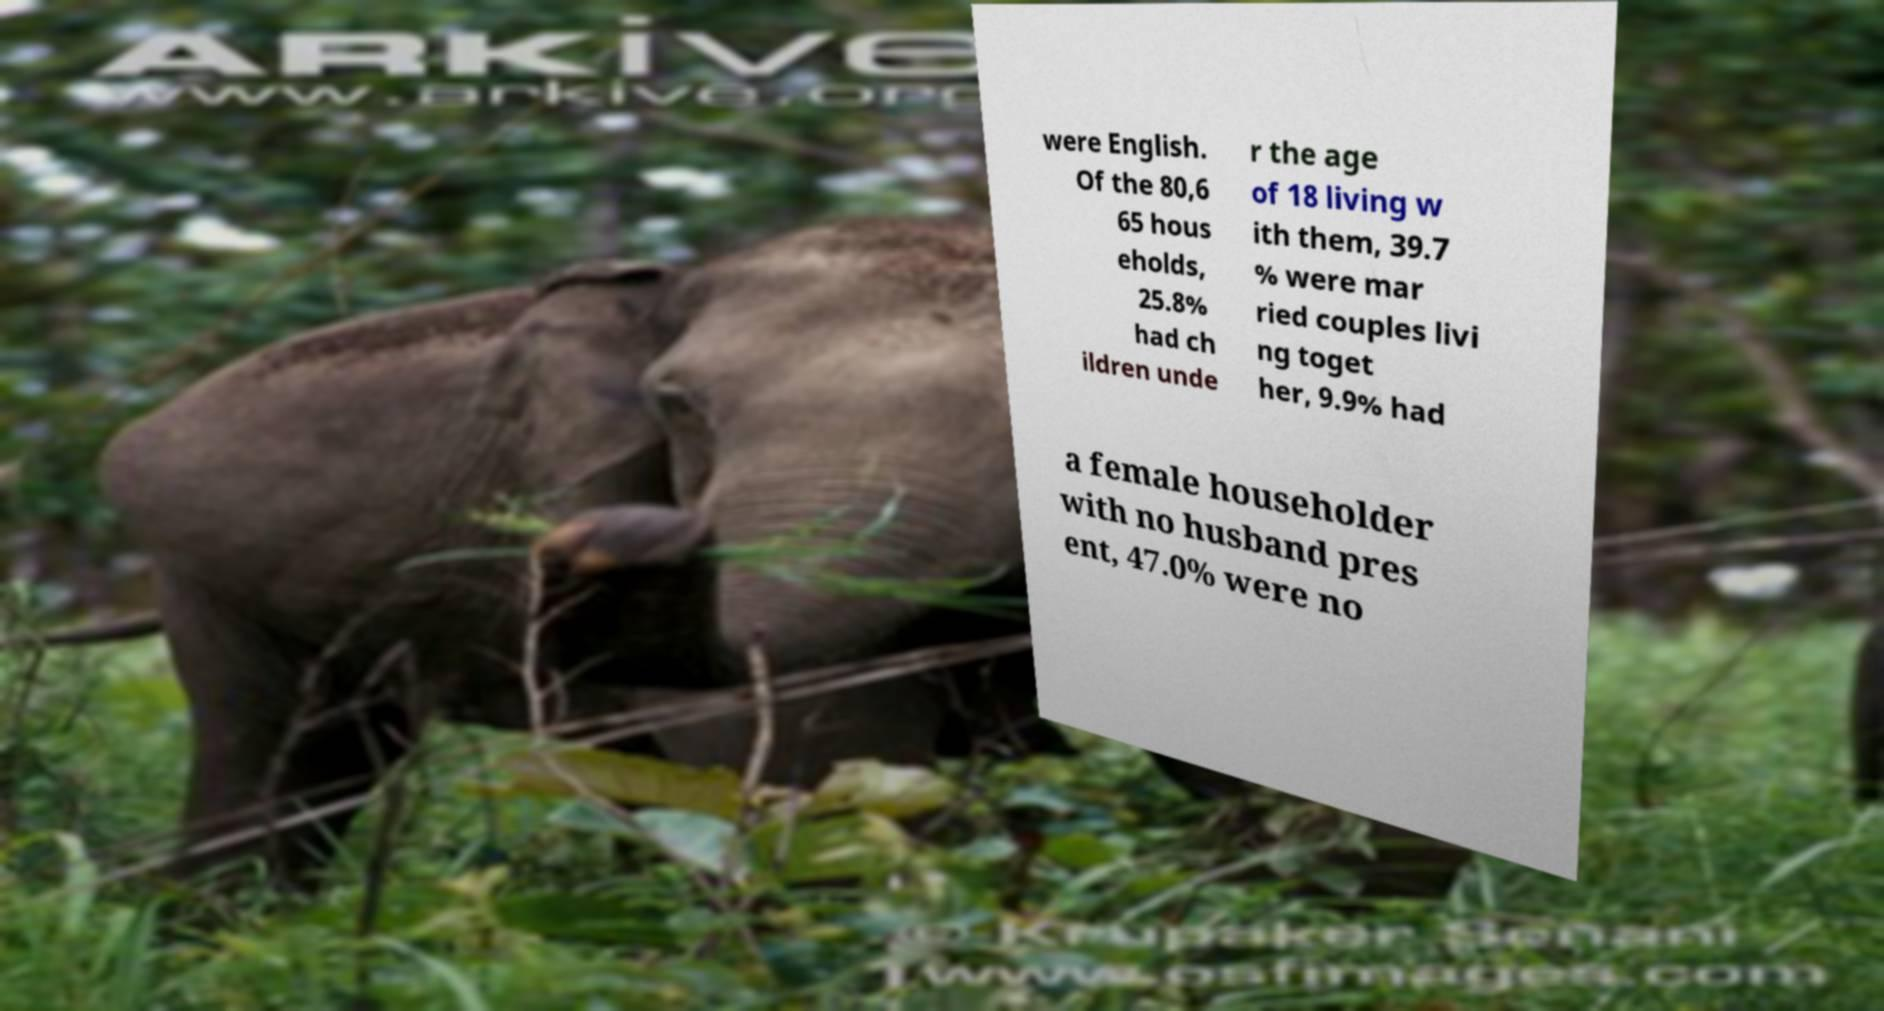There's text embedded in this image that I need extracted. Can you transcribe it verbatim? were English. Of the 80,6 65 hous eholds, 25.8% had ch ildren unde r the age of 18 living w ith them, 39.7 % were mar ried couples livi ng toget her, 9.9% had a female householder with no husband pres ent, 47.0% were no 